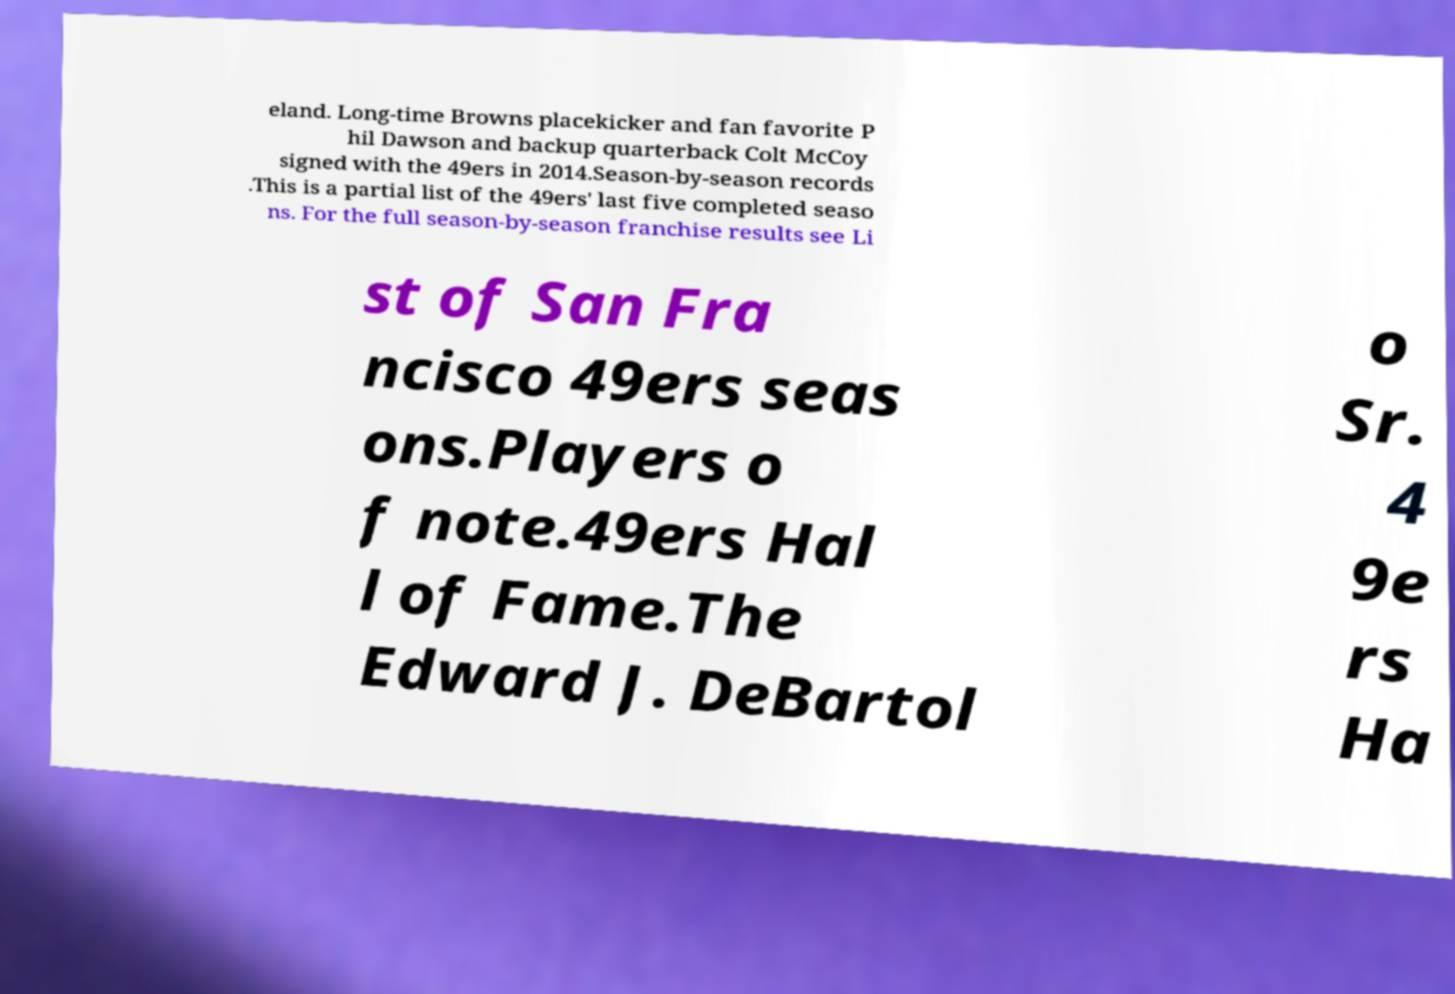Could you assist in decoding the text presented in this image and type it out clearly? eland. Long-time Browns placekicker and fan favorite P hil Dawson and backup quarterback Colt McCoy signed with the 49ers in 2014.Season-by-season records .This is a partial list of the 49ers' last five completed seaso ns. For the full season-by-season franchise results see Li st of San Fra ncisco 49ers seas ons.Players o f note.49ers Hal l of Fame.The Edward J. DeBartol o Sr. 4 9e rs Ha 